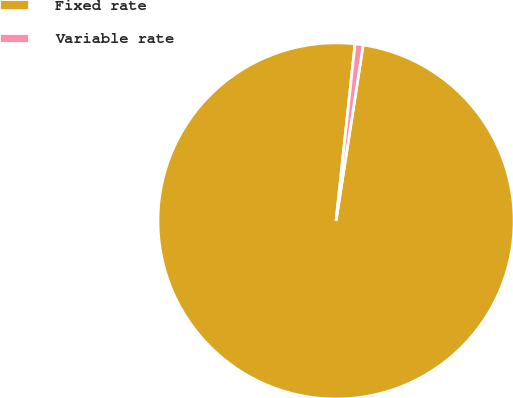<chart> <loc_0><loc_0><loc_500><loc_500><pie_chart><fcel>Fixed rate<fcel>Variable rate<nl><fcel>99.27%<fcel>0.73%<nl></chart> 